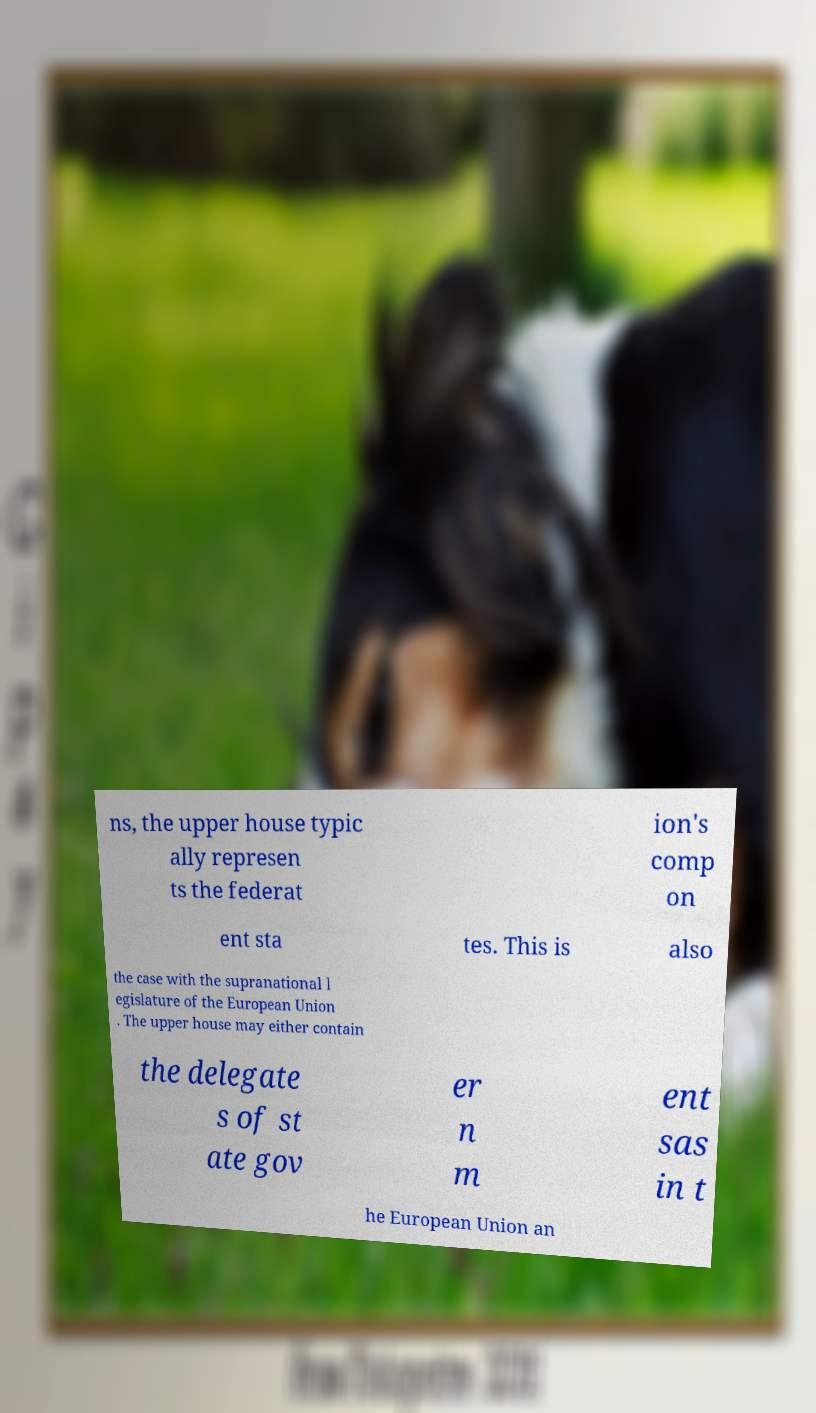Could you extract and type out the text from this image? ns, the upper house typic ally represen ts the federat ion's comp on ent sta tes. This is also the case with the supranational l egislature of the European Union . The upper house may either contain the delegate s of st ate gov er n m ent sas in t he European Union an 